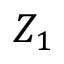Convert formula to latex. <formula><loc_0><loc_0><loc_500><loc_500>Z _ { 1 }</formula> 